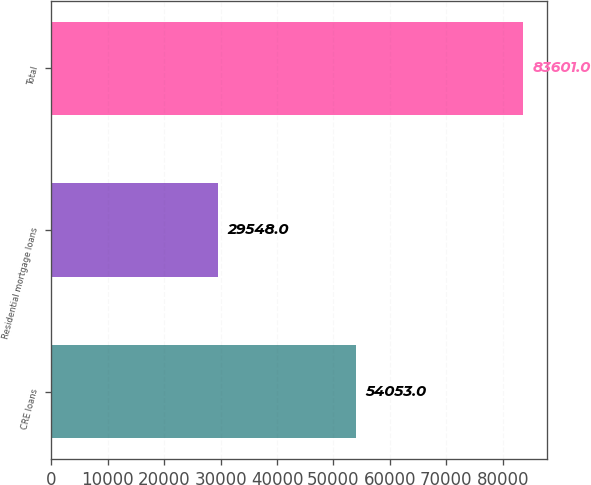<chart> <loc_0><loc_0><loc_500><loc_500><bar_chart><fcel>CRE loans<fcel>Residential mortgage loans<fcel>Total<nl><fcel>54053<fcel>29548<fcel>83601<nl></chart> 